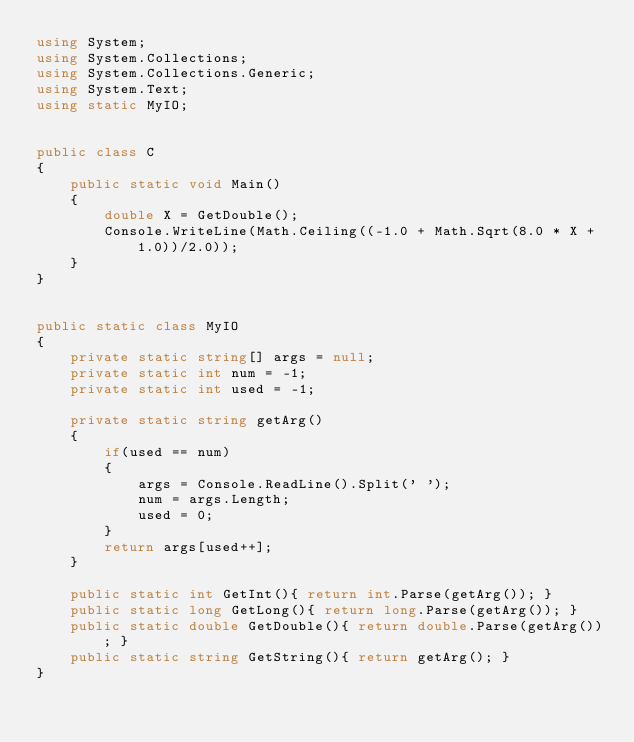<code> <loc_0><loc_0><loc_500><loc_500><_C#_>using System;
using System.Collections;
using System.Collections.Generic;
using System.Text;
using static MyIO;


public class C
{
	public static void Main()	
	{
		double X = GetDouble();
		Console.WriteLine(Math.Ceiling((-1.0 + Math.Sqrt(8.0 * X + 1.0))/2.0));
	}
}


public static class MyIO
{
	private static string[] args = null;
	private static int num = -1;
	private static int used = -1;

	private static string getArg()
	{
		if(used == num)
		{
			args = Console.ReadLine().Split(' ');
			num = args.Length;
			used = 0;
		}
		return args[used++];
	}

	public static int GetInt(){ return int.Parse(getArg()); }
	public static long GetLong(){ return long.Parse(getArg()); }
	public static double GetDouble(){ return double.Parse(getArg()); }
	public static string GetString(){ return getArg(); }
}
</code> 